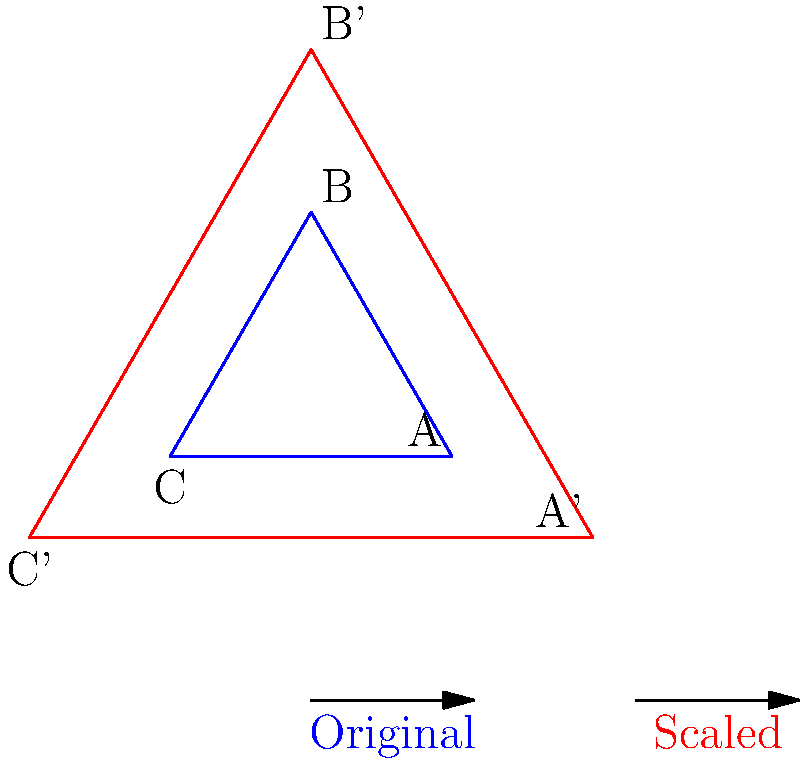The property manager of your exclusive beachfront community wants to create a larger display of the neighborhood map for the community center. The original map is represented by triangle ABC, and the scaled version is represented by triangle A'B'C'. If the distance between points A and B on the original map is 5 inches, what is the distance between points A' and B' on the scaled map? To solve this problem, we need to understand the concept of scaling in transformational geometry. Let's break it down step-by-step:

1. Observe the given information:
   - The original map is represented by triangle ABC.
   - The scaled map is represented by triangle A'B'C'.
   - The distance between points A and B on the original map is 5 inches.

2. Identify the scale factor:
   - By comparing the sizes of the two triangles in the diagram, we can see that the scaled triangle is twice as large as the original.
   - This means the scale factor is 2.

3. Apply the scaling principle:
   - When a figure is scaled by a factor of k, all linear dimensions are multiplied by k.
   - In this case, k = 2.

4. Calculate the new distance:
   - Original distance between A and B = 5 inches
   - Scaled distance between A' and B' = 5 * 2 = 10 inches

Therefore, the distance between points A' and B' on the scaled map is 10 inches.
Answer: 10 inches 